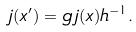Convert formula to latex. <formula><loc_0><loc_0><loc_500><loc_500>j ( x ^ { \prime } ) = g \, j ( x ) h ^ { - 1 } .</formula> 